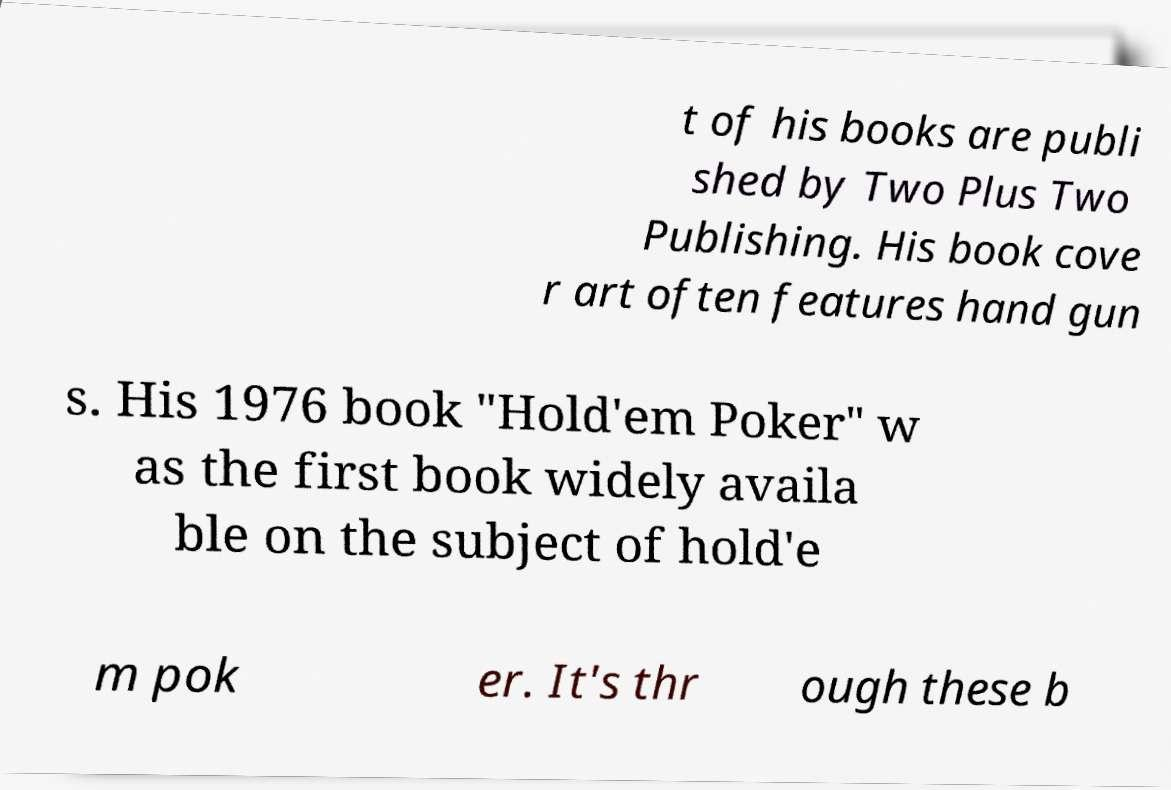Could you extract and type out the text from this image? t of his books are publi shed by Two Plus Two Publishing. His book cove r art often features hand gun s. His 1976 book "Hold'em Poker" w as the first book widely availa ble on the subject of hold'e m pok er. It's thr ough these b 